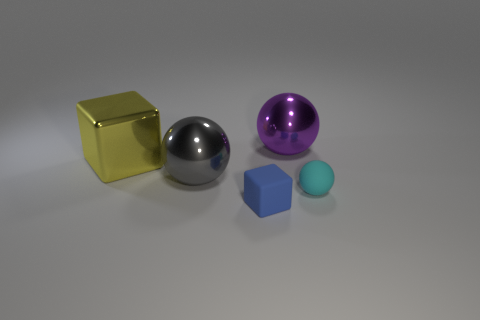What number of yellow metallic cylinders are there?
Offer a terse response. 0. Is there a yellow cube of the same size as the yellow object?
Ensure brevity in your answer.  No. Are there fewer cyan things that are left of the small sphere than large cyan shiny things?
Offer a terse response. No. Do the gray metal object and the yellow metal block have the same size?
Your answer should be compact. Yes. What size is the other sphere that is made of the same material as the big purple ball?
Your response must be concise. Large. How many other large balls have the same color as the matte ball?
Your answer should be very brief. 0. Is the number of gray balls that are left of the large gray metal sphere less than the number of large purple spheres that are behind the large metal block?
Provide a succinct answer. Yes. Is the shape of the rubber thing to the right of the blue rubber cube the same as  the blue rubber thing?
Give a very brief answer. No. Is there any other thing that is made of the same material as the blue cube?
Provide a short and direct response. Yes. Is the big sphere behind the big metal cube made of the same material as the yellow cube?
Your response must be concise. Yes. 